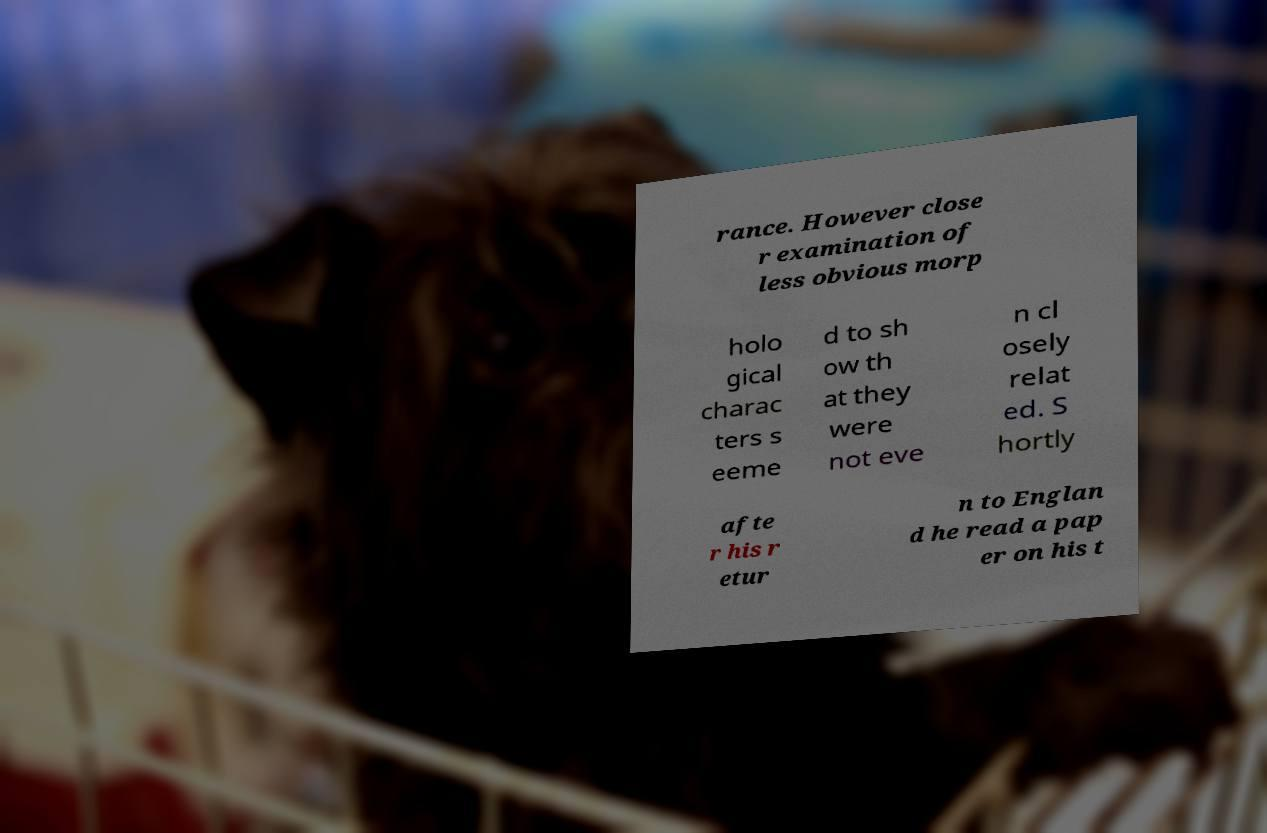Can you accurately transcribe the text from the provided image for me? rance. However close r examination of less obvious morp holo gical charac ters s eeme d to sh ow th at they were not eve n cl osely relat ed. S hortly afte r his r etur n to Englan d he read a pap er on his t 